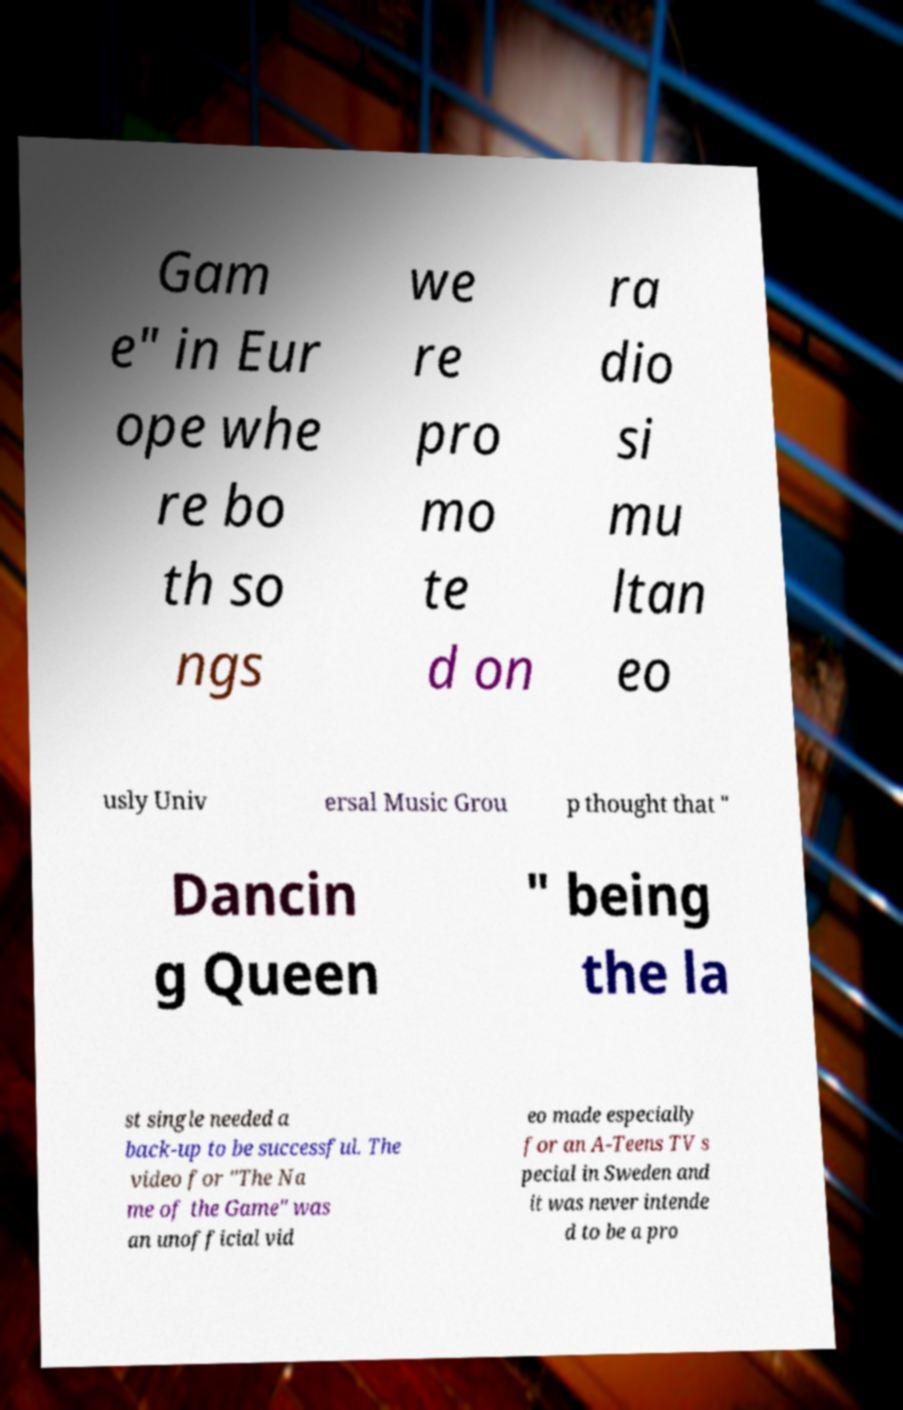I need the written content from this picture converted into text. Can you do that? Gam e" in Eur ope whe re bo th so ngs we re pro mo te d on ra dio si mu ltan eo usly Univ ersal Music Grou p thought that " Dancin g Queen " being the la st single needed a back-up to be successful. The video for "The Na me of the Game" was an unofficial vid eo made especially for an A-Teens TV s pecial in Sweden and it was never intende d to be a pro 